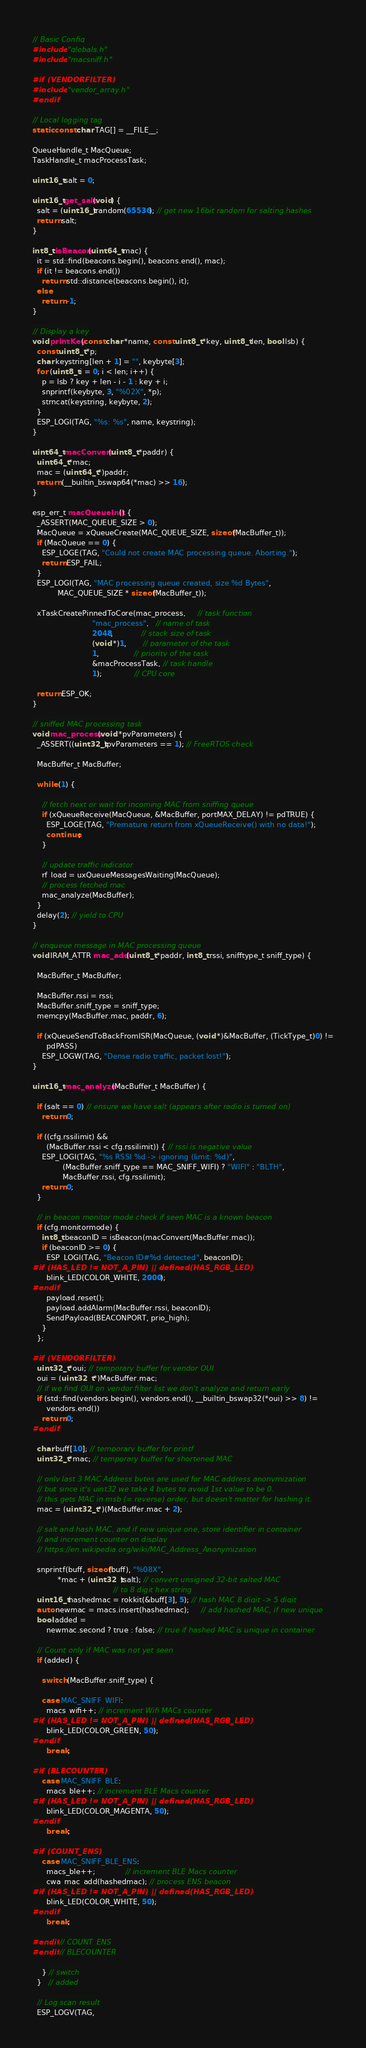Convert code to text. <code><loc_0><loc_0><loc_500><loc_500><_C++_>
// Basic Config
#include "globals.h"
#include "macsniff.h"

#if (VENDORFILTER)
#include "vendor_array.h"
#endif

// Local logging tag
static const char TAG[] = __FILE__;

QueueHandle_t MacQueue;
TaskHandle_t macProcessTask;

uint16_t salt = 0;

uint16_t get_salt(void) {
  salt = (uint16_t)random(65536); // get new 16bit random for salting hashes
  return salt;
}

int8_t isBeacon(uint64_t mac) {
  it = std::find(beacons.begin(), beacons.end(), mac);
  if (it != beacons.end())
    return std::distance(beacons.begin(), it);
  else
    return -1;
}

// Display a key
void printKey(const char *name, const uint8_t *key, uint8_t len, bool lsb) {
  const uint8_t *p;
  char keystring[len + 1] = "", keybyte[3];
  for (uint8_t i = 0; i < len; i++) {
    p = lsb ? key + len - i - 1 : key + i;
    snprintf(keybyte, 3, "%02X", *p);
    strncat(keystring, keybyte, 2);
  }
  ESP_LOGI(TAG, "%s: %s", name, keystring);
}

uint64_t macConvert(uint8_t *paddr) {
  uint64_t *mac;
  mac = (uint64_t *)paddr;
  return (__builtin_bswap64(*mac) >> 16);
}

esp_err_t macQueueInit() {
  _ASSERT(MAC_QUEUE_SIZE > 0);
  MacQueue = xQueueCreate(MAC_QUEUE_SIZE, sizeof(MacBuffer_t));
  if (MacQueue == 0) {
    ESP_LOGE(TAG, "Could not create MAC processing queue. Aborting.");
    return ESP_FAIL;
  }
  ESP_LOGI(TAG, "MAC processing queue created, size %d Bytes",
           MAC_QUEUE_SIZE * sizeof(MacBuffer_t));

  xTaskCreatePinnedToCore(mac_process,     // task function
                          "mac_process",   // name of task
                          2048,            // stack size of task
                          (void *)1,       // parameter of the task
                          1,               // priority of the task
                          &macProcessTask, // task handle
                          1);              // CPU core

  return ESP_OK;
}

// sniffed MAC processing task
void mac_process(void *pvParameters) {
  _ASSERT((uint32_t)pvParameters == 1); // FreeRTOS check

  MacBuffer_t MacBuffer;

  while (1) {

    // fetch next or wait for incoming MAC from sniffing queue
    if (xQueueReceive(MacQueue, &MacBuffer, portMAX_DELAY) != pdTRUE) {
      ESP_LOGE(TAG, "Premature return from xQueueReceive() with no data!");
      continue;
    }

    // update traffic indicator
    rf_load = uxQueueMessagesWaiting(MacQueue);
    // process fetched mac
    mac_analyze(MacBuffer);
  }
  delay(2); // yield to CPU
}

// enqueue message in MAC processing queue
void IRAM_ATTR mac_add(uint8_t *paddr, int8_t rssi, snifftype_t sniff_type) {

  MacBuffer_t MacBuffer;

  MacBuffer.rssi = rssi;
  MacBuffer.sniff_type = sniff_type;
  memcpy(MacBuffer.mac, paddr, 6);

  if (xQueueSendToBackFromISR(MacQueue, (void *)&MacBuffer, (TickType_t)0) !=
      pdPASS)
    ESP_LOGW(TAG, "Dense radio traffic, packet lost!");
}

uint16_t mac_analyze(MacBuffer_t MacBuffer) {

  if (salt == 0) // ensure we have salt (appears after radio is turned on)
    return 0;

  if ((cfg.rssilimit) &&
      (MacBuffer.rssi < cfg.rssilimit)) { // rssi is negative value
    ESP_LOGI(TAG, "%s RSSI %d -> ignoring (limit: %d)",
             (MacBuffer.sniff_type == MAC_SNIFF_WIFI) ? "WIFI" : "BLTH",
             MacBuffer.rssi, cfg.rssilimit);
    return 0;
  }

  // in beacon monitor mode check if seen MAC is a known beacon
  if (cfg.monitormode) {
    int8_t beaconID = isBeacon(macConvert(MacBuffer.mac));
    if (beaconID >= 0) {
      ESP_LOGI(TAG, "Beacon ID#%d detected", beaconID);
#if (HAS_LED != NOT_A_PIN) || defined(HAS_RGB_LED)
      blink_LED(COLOR_WHITE, 2000);
#endif
      payload.reset();
      payload.addAlarm(MacBuffer.rssi, beaconID);
      SendPayload(BEACONPORT, prio_high);
    }
  };

#if (VENDORFILTER)
  uint32_t *oui; // temporary buffer for vendor OUI
  oui = (uint32_t *)MacBuffer.mac;
  // if we find OUI on vendor filter list we don't analyze and return early
  if (std::find(vendors.begin(), vendors.end(), __builtin_bswap32(*oui) >> 8) !=
      vendors.end())
    return 0;
#endif

  char buff[10]; // temporary buffer for printf
  uint32_t *mac; // temporary buffer for shortened MAC

  // only last 3 MAC Address bytes are used for MAC address anonymization
  // but since it's uint32 we take 4 bytes to avoid 1st value to be 0.
  // this gets MAC in msb (= reverse) order, but doesn't matter for hashing it.
  mac = (uint32_t *)(MacBuffer.mac + 2);

  // salt and hash MAC, and if new unique one, store identifier in container
  // and increment counter on display
  // https://en.wikipedia.org/wiki/MAC_Address_Anonymization

  snprintf(buff, sizeof(buff), "%08X",
           *mac + (uint32_t)salt); // convert unsigned 32-bit salted MAC
                                   // to 8 digit hex string
  uint16_t hashedmac = rokkit(&buff[3], 5); // hash MAC 8 digit -> 5 digit
  auto newmac = macs.insert(hashedmac);     // add hashed MAC, if new unique
  bool added =
      newmac.second ? true : false; // true if hashed MAC is unique in container

  // Count only if MAC was not yet seen
  if (added) {

    switch (MacBuffer.sniff_type) {

    case MAC_SNIFF_WIFI:
      macs_wifi++; // increment Wifi MACs counter
#if (HAS_LED != NOT_A_PIN) || defined(HAS_RGB_LED)
      blink_LED(COLOR_GREEN, 50);
#endif
      break;

#if (BLECOUNTER)
    case MAC_SNIFF_BLE:
      macs_ble++; // increment BLE Macs counter
#if (HAS_LED != NOT_A_PIN) || defined(HAS_RGB_LED)
      blink_LED(COLOR_MAGENTA, 50);
#endif
      break;

#if (COUNT_ENS)
    case MAC_SNIFF_BLE_ENS:
      macs_ble++;             // increment BLE Macs counter
      cwa_mac_add(hashedmac); // process ENS beacon
#if (HAS_LED != NOT_A_PIN) || defined(HAS_RGB_LED)
      blink_LED(COLOR_WHITE, 50);
#endif
      break;

#endif // COUNT_ENS
#endif // BLECOUNTER

    } // switch
  }   // added

  // Log scan result
  ESP_LOGV(TAG,</code> 